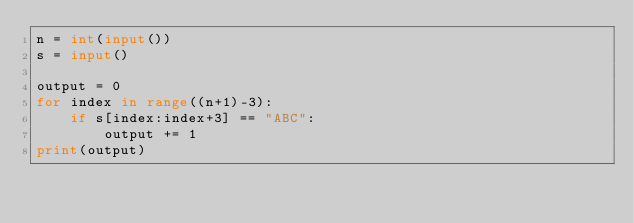<code> <loc_0><loc_0><loc_500><loc_500><_Python_>n = int(input())
s = input()

output = 0
for index in range((n+1)-3):
    if s[index:index+3] == "ABC":
        output += 1
print(output)</code> 